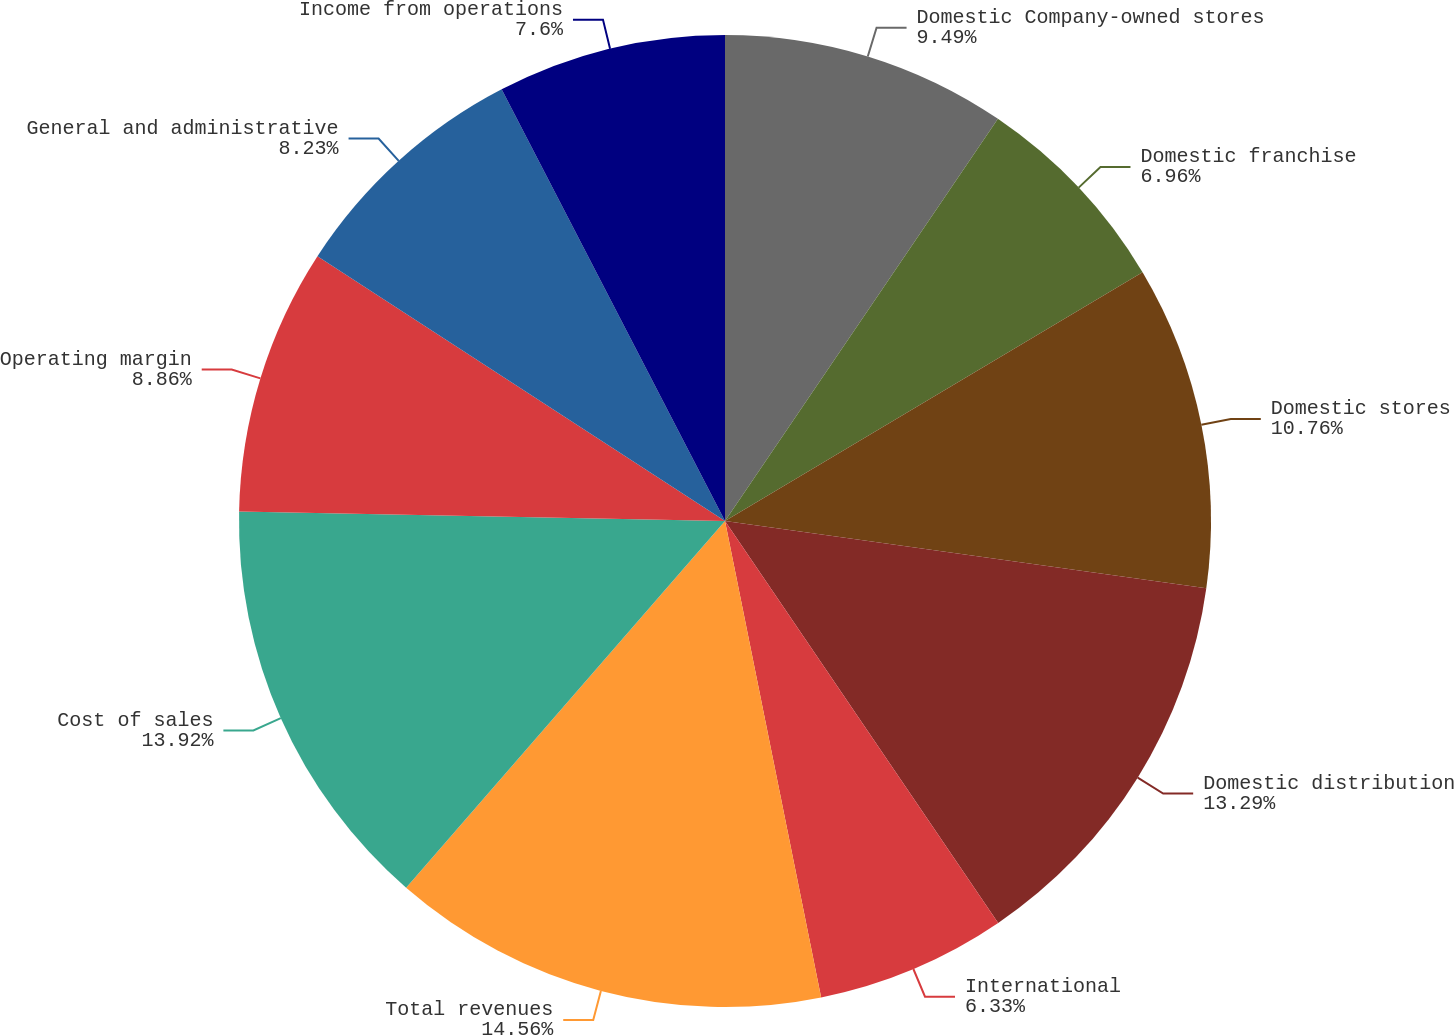Convert chart. <chart><loc_0><loc_0><loc_500><loc_500><pie_chart><fcel>Domestic Company-owned stores<fcel>Domestic franchise<fcel>Domestic stores<fcel>Domestic distribution<fcel>International<fcel>Total revenues<fcel>Cost of sales<fcel>Operating margin<fcel>General and administrative<fcel>Income from operations<nl><fcel>9.49%<fcel>6.96%<fcel>10.76%<fcel>13.29%<fcel>6.33%<fcel>14.56%<fcel>13.92%<fcel>8.86%<fcel>8.23%<fcel>7.6%<nl></chart> 